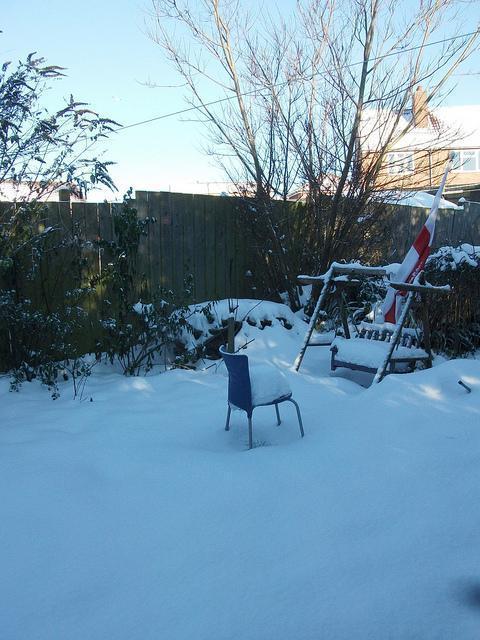How many posts in the nearest segment of fence?
Give a very brief answer. 1. How many people are wearing red shirts?
Give a very brief answer. 0. 